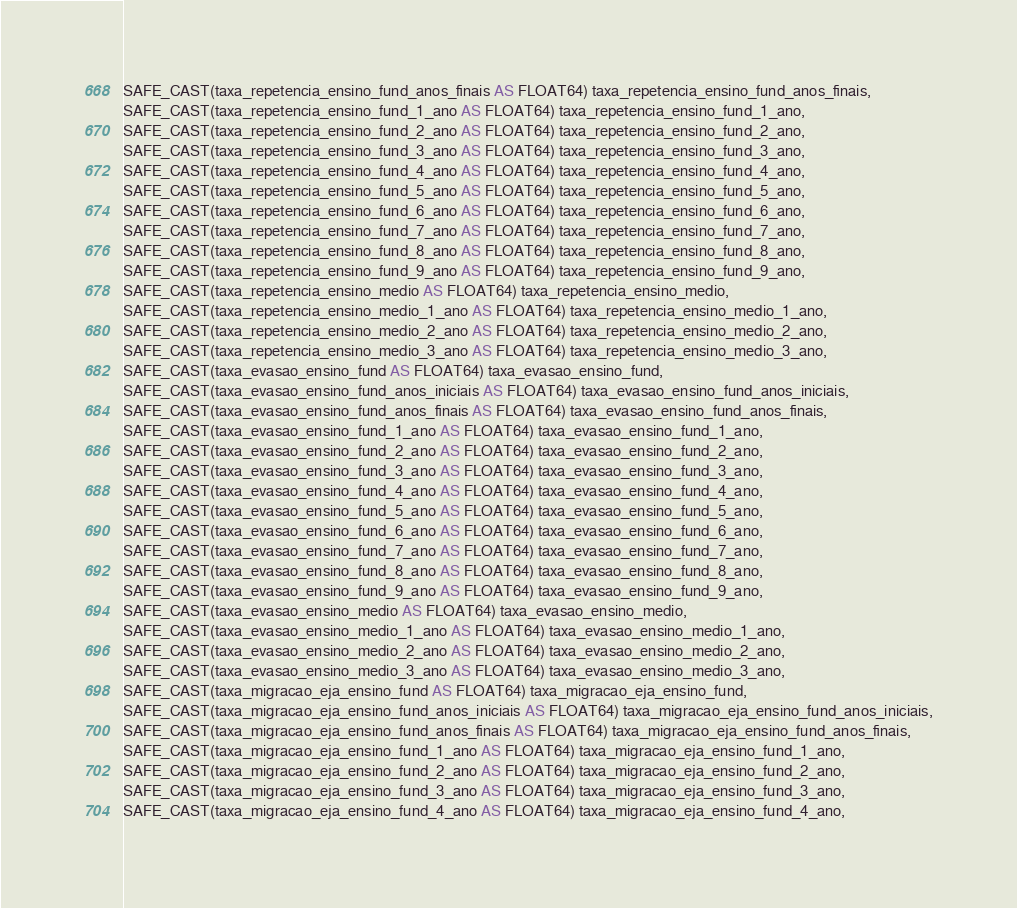<code> <loc_0><loc_0><loc_500><loc_500><_SQL_>SAFE_CAST(taxa_repetencia_ensino_fund_anos_finais AS FLOAT64) taxa_repetencia_ensino_fund_anos_finais,
SAFE_CAST(taxa_repetencia_ensino_fund_1_ano AS FLOAT64) taxa_repetencia_ensino_fund_1_ano,
SAFE_CAST(taxa_repetencia_ensino_fund_2_ano AS FLOAT64) taxa_repetencia_ensino_fund_2_ano,
SAFE_CAST(taxa_repetencia_ensino_fund_3_ano AS FLOAT64) taxa_repetencia_ensino_fund_3_ano,
SAFE_CAST(taxa_repetencia_ensino_fund_4_ano AS FLOAT64) taxa_repetencia_ensino_fund_4_ano,
SAFE_CAST(taxa_repetencia_ensino_fund_5_ano AS FLOAT64) taxa_repetencia_ensino_fund_5_ano,
SAFE_CAST(taxa_repetencia_ensino_fund_6_ano AS FLOAT64) taxa_repetencia_ensino_fund_6_ano,
SAFE_CAST(taxa_repetencia_ensino_fund_7_ano AS FLOAT64) taxa_repetencia_ensino_fund_7_ano,
SAFE_CAST(taxa_repetencia_ensino_fund_8_ano AS FLOAT64) taxa_repetencia_ensino_fund_8_ano,
SAFE_CAST(taxa_repetencia_ensino_fund_9_ano AS FLOAT64) taxa_repetencia_ensino_fund_9_ano,
SAFE_CAST(taxa_repetencia_ensino_medio AS FLOAT64) taxa_repetencia_ensino_medio,
SAFE_CAST(taxa_repetencia_ensino_medio_1_ano AS FLOAT64) taxa_repetencia_ensino_medio_1_ano,
SAFE_CAST(taxa_repetencia_ensino_medio_2_ano AS FLOAT64) taxa_repetencia_ensino_medio_2_ano,
SAFE_CAST(taxa_repetencia_ensino_medio_3_ano AS FLOAT64) taxa_repetencia_ensino_medio_3_ano,
SAFE_CAST(taxa_evasao_ensino_fund AS FLOAT64) taxa_evasao_ensino_fund,
SAFE_CAST(taxa_evasao_ensino_fund_anos_iniciais AS FLOAT64) taxa_evasao_ensino_fund_anos_iniciais,
SAFE_CAST(taxa_evasao_ensino_fund_anos_finais AS FLOAT64) taxa_evasao_ensino_fund_anos_finais,
SAFE_CAST(taxa_evasao_ensino_fund_1_ano AS FLOAT64) taxa_evasao_ensino_fund_1_ano,
SAFE_CAST(taxa_evasao_ensino_fund_2_ano AS FLOAT64) taxa_evasao_ensino_fund_2_ano,
SAFE_CAST(taxa_evasao_ensino_fund_3_ano AS FLOAT64) taxa_evasao_ensino_fund_3_ano,
SAFE_CAST(taxa_evasao_ensino_fund_4_ano AS FLOAT64) taxa_evasao_ensino_fund_4_ano,
SAFE_CAST(taxa_evasao_ensino_fund_5_ano AS FLOAT64) taxa_evasao_ensino_fund_5_ano,
SAFE_CAST(taxa_evasao_ensino_fund_6_ano AS FLOAT64) taxa_evasao_ensino_fund_6_ano,
SAFE_CAST(taxa_evasao_ensino_fund_7_ano AS FLOAT64) taxa_evasao_ensino_fund_7_ano,
SAFE_CAST(taxa_evasao_ensino_fund_8_ano AS FLOAT64) taxa_evasao_ensino_fund_8_ano,
SAFE_CAST(taxa_evasao_ensino_fund_9_ano AS FLOAT64) taxa_evasao_ensino_fund_9_ano,
SAFE_CAST(taxa_evasao_ensino_medio AS FLOAT64) taxa_evasao_ensino_medio,
SAFE_CAST(taxa_evasao_ensino_medio_1_ano AS FLOAT64) taxa_evasao_ensino_medio_1_ano,
SAFE_CAST(taxa_evasao_ensino_medio_2_ano AS FLOAT64) taxa_evasao_ensino_medio_2_ano,
SAFE_CAST(taxa_evasao_ensino_medio_3_ano AS FLOAT64) taxa_evasao_ensino_medio_3_ano,
SAFE_CAST(taxa_migracao_eja_ensino_fund AS FLOAT64) taxa_migracao_eja_ensino_fund,
SAFE_CAST(taxa_migracao_eja_ensino_fund_anos_iniciais AS FLOAT64) taxa_migracao_eja_ensino_fund_anos_iniciais,
SAFE_CAST(taxa_migracao_eja_ensino_fund_anos_finais AS FLOAT64) taxa_migracao_eja_ensino_fund_anos_finais,
SAFE_CAST(taxa_migracao_eja_ensino_fund_1_ano AS FLOAT64) taxa_migracao_eja_ensino_fund_1_ano,
SAFE_CAST(taxa_migracao_eja_ensino_fund_2_ano AS FLOAT64) taxa_migracao_eja_ensino_fund_2_ano,
SAFE_CAST(taxa_migracao_eja_ensino_fund_3_ano AS FLOAT64) taxa_migracao_eja_ensino_fund_3_ano,
SAFE_CAST(taxa_migracao_eja_ensino_fund_4_ano AS FLOAT64) taxa_migracao_eja_ensino_fund_4_ano,</code> 